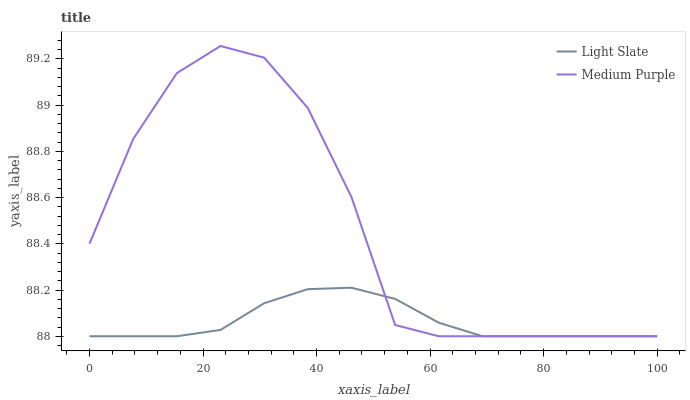Does Light Slate have the minimum area under the curve?
Answer yes or no. Yes. Does Medium Purple have the maximum area under the curve?
Answer yes or no. Yes. Does Medium Purple have the minimum area under the curve?
Answer yes or no. No. Is Light Slate the smoothest?
Answer yes or no. Yes. Is Medium Purple the roughest?
Answer yes or no. Yes. Is Medium Purple the smoothest?
Answer yes or no. No. 